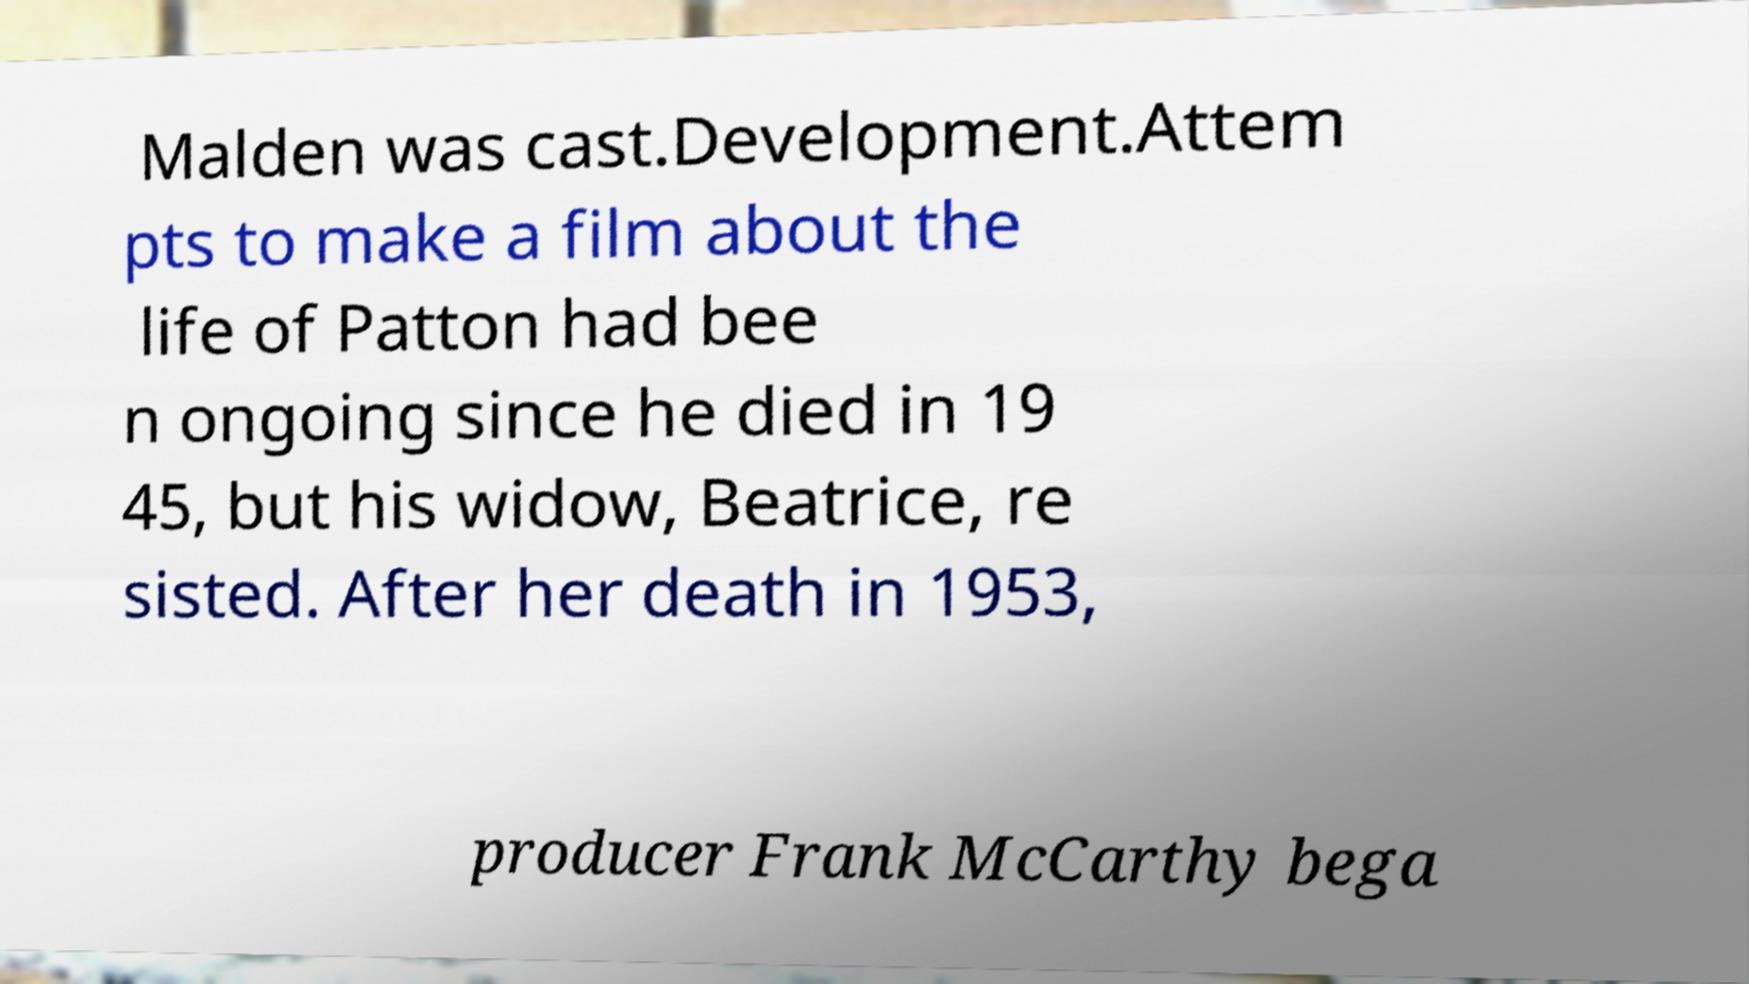Can you accurately transcribe the text from the provided image for me? Malden was cast.Development.Attem pts to make a film about the life of Patton had bee n ongoing since he died in 19 45, but his widow, Beatrice, re sisted. After her death in 1953, producer Frank McCarthy bega 